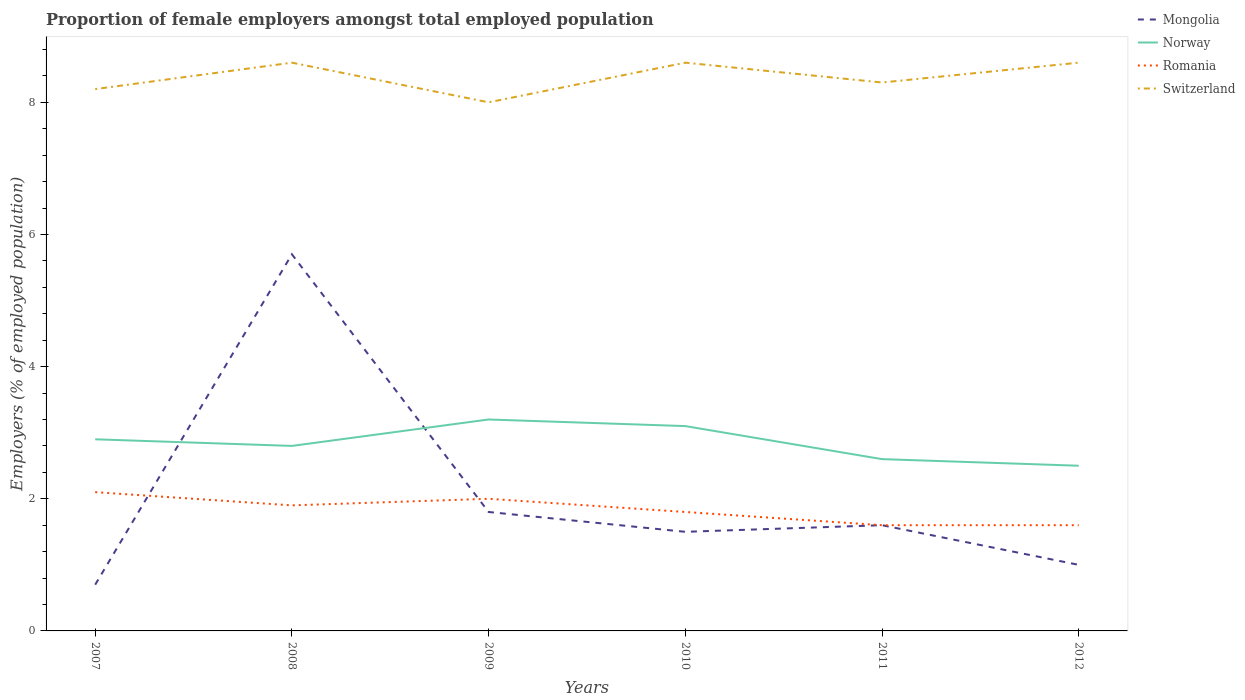Does the line corresponding to Switzerland intersect with the line corresponding to Norway?
Keep it short and to the point. No. In which year was the proportion of female employers in Norway maximum?
Your answer should be compact. 2012. What is the total proportion of female employers in Mongolia in the graph?
Offer a terse response. 4.7. What is the difference between the highest and the second highest proportion of female employers in Switzerland?
Provide a short and direct response. 0.6. What is the difference between the highest and the lowest proportion of female employers in Switzerland?
Your answer should be very brief. 3. Is the proportion of female employers in Norway strictly greater than the proportion of female employers in Romania over the years?
Your answer should be compact. No. How many lines are there?
Offer a very short reply. 4. How many years are there in the graph?
Ensure brevity in your answer.  6. Does the graph contain any zero values?
Offer a terse response. No. Does the graph contain grids?
Your answer should be compact. No. Where does the legend appear in the graph?
Ensure brevity in your answer.  Top right. How are the legend labels stacked?
Offer a very short reply. Vertical. What is the title of the graph?
Offer a very short reply. Proportion of female employers amongst total employed population. What is the label or title of the X-axis?
Keep it short and to the point. Years. What is the label or title of the Y-axis?
Provide a short and direct response. Employers (% of employed population). What is the Employers (% of employed population) in Mongolia in 2007?
Your answer should be compact. 0.7. What is the Employers (% of employed population) in Norway in 2007?
Give a very brief answer. 2.9. What is the Employers (% of employed population) in Romania in 2007?
Make the answer very short. 2.1. What is the Employers (% of employed population) in Switzerland in 2007?
Give a very brief answer. 8.2. What is the Employers (% of employed population) in Mongolia in 2008?
Provide a succinct answer. 5.7. What is the Employers (% of employed population) in Norway in 2008?
Make the answer very short. 2.8. What is the Employers (% of employed population) of Romania in 2008?
Give a very brief answer. 1.9. What is the Employers (% of employed population) of Switzerland in 2008?
Give a very brief answer. 8.6. What is the Employers (% of employed population) of Mongolia in 2009?
Make the answer very short. 1.8. What is the Employers (% of employed population) of Norway in 2009?
Ensure brevity in your answer.  3.2. What is the Employers (% of employed population) in Romania in 2009?
Your response must be concise. 2. What is the Employers (% of employed population) in Norway in 2010?
Ensure brevity in your answer.  3.1. What is the Employers (% of employed population) of Romania in 2010?
Your answer should be compact. 1.8. What is the Employers (% of employed population) in Switzerland in 2010?
Provide a succinct answer. 8.6. What is the Employers (% of employed population) in Mongolia in 2011?
Provide a succinct answer. 1.6. What is the Employers (% of employed population) in Norway in 2011?
Offer a very short reply. 2.6. What is the Employers (% of employed population) in Romania in 2011?
Make the answer very short. 1.6. What is the Employers (% of employed population) of Switzerland in 2011?
Your response must be concise. 8.3. What is the Employers (% of employed population) of Mongolia in 2012?
Offer a very short reply. 1. What is the Employers (% of employed population) of Romania in 2012?
Ensure brevity in your answer.  1.6. What is the Employers (% of employed population) of Switzerland in 2012?
Ensure brevity in your answer.  8.6. Across all years, what is the maximum Employers (% of employed population) in Mongolia?
Make the answer very short. 5.7. Across all years, what is the maximum Employers (% of employed population) in Norway?
Offer a terse response. 3.2. Across all years, what is the maximum Employers (% of employed population) of Romania?
Give a very brief answer. 2.1. Across all years, what is the maximum Employers (% of employed population) of Switzerland?
Ensure brevity in your answer.  8.6. Across all years, what is the minimum Employers (% of employed population) in Mongolia?
Offer a very short reply. 0.7. Across all years, what is the minimum Employers (% of employed population) in Romania?
Provide a short and direct response. 1.6. What is the total Employers (% of employed population) of Mongolia in the graph?
Offer a terse response. 12.3. What is the total Employers (% of employed population) in Switzerland in the graph?
Your response must be concise. 50.3. What is the difference between the Employers (% of employed population) of Norway in 2007 and that in 2008?
Provide a succinct answer. 0.1. What is the difference between the Employers (% of employed population) of Mongolia in 2007 and that in 2009?
Make the answer very short. -1.1. What is the difference between the Employers (% of employed population) in Romania in 2007 and that in 2009?
Keep it short and to the point. 0.1. What is the difference between the Employers (% of employed population) in Switzerland in 2007 and that in 2010?
Keep it short and to the point. -0.4. What is the difference between the Employers (% of employed population) in Mongolia in 2007 and that in 2011?
Provide a short and direct response. -0.9. What is the difference between the Employers (% of employed population) in Norway in 2007 and that in 2011?
Provide a short and direct response. 0.3. What is the difference between the Employers (% of employed population) of Romania in 2007 and that in 2011?
Your response must be concise. 0.5. What is the difference between the Employers (% of employed population) of Switzerland in 2007 and that in 2011?
Offer a terse response. -0.1. What is the difference between the Employers (% of employed population) in Mongolia in 2007 and that in 2012?
Keep it short and to the point. -0.3. What is the difference between the Employers (% of employed population) in Switzerland in 2007 and that in 2012?
Make the answer very short. -0.4. What is the difference between the Employers (% of employed population) in Mongolia in 2008 and that in 2009?
Make the answer very short. 3.9. What is the difference between the Employers (% of employed population) of Switzerland in 2008 and that in 2009?
Your answer should be compact. 0.6. What is the difference between the Employers (% of employed population) in Norway in 2008 and that in 2010?
Make the answer very short. -0.3. What is the difference between the Employers (% of employed population) in Romania in 2008 and that in 2010?
Offer a very short reply. 0.1. What is the difference between the Employers (% of employed population) in Switzerland in 2008 and that in 2010?
Offer a very short reply. 0. What is the difference between the Employers (% of employed population) in Norway in 2008 and that in 2011?
Your response must be concise. 0.2. What is the difference between the Employers (% of employed population) in Romania in 2008 and that in 2011?
Offer a terse response. 0.3. What is the difference between the Employers (% of employed population) in Mongolia in 2008 and that in 2012?
Make the answer very short. 4.7. What is the difference between the Employers (% of employed population) of Norway in 2008 and that in 2012?
Give a very brief answer. 0.3. What is the difference between the Employers (% of employed population) in Switzerland in 2008 and that in 2012?
Offer a very short reply. 0. What is the difference between the Employers (% of employed population) of Mongolia in 2009 and that in 2012?
Provide a succinct answer. 0.8. What is the difference between the Employers (% of employed population) of Mongolia in 2010 and that in 2011?
Give a very brief answer. -0.1. What is the difference between the Employers (% of employed population) in Romania in 2010 and that in 2011?
Provide a short and direct response. 0.2. What is the difference between the Employers (% of employed population) in Switzerland in 2010 and that in 2012?
Offer a very short reply. 0. What is the difference between the Employers (% of employed population) of Norway in 2011 and that in 2012?
Offer a terse response. 0.1. What is the difference between the Employers (% of employed population) in Romania in 2011 and that in 2012?
Offer a very short reply. 0. What is the difference between the Employers (% of employed population) in Mongolia in 2007 and the Employers (% of employed population) in Norway in 2009?
Provide a short and direct response. -2.5. What is the difference between the Employers (% of employed population) of Mongolia in 2007 and the Employers (% of employed population) of Switzerland in 2009?
Ensure brevity in your answer.  -7.3. What is the difference between the Employers (% of employed population) of Norway in 2007 and the Employers (% of employed population) of Romania in 2009?
Ensure brevity in your answer.  0.9. What is the difference between the Employers (% of employed population) in Romania in 2007 and the Employers (% of employed population) in Switzerland in 2009?
Offer a terse response. -5.9. What is the difference between the Employers (% of employed population) in Mongolia in 2007 and the Employers (% of employed population) in Romania in 2010?
Your answer should be compact. -1.1. What is the difference between the Employers (% of employed population) of Mongolia in 2007 and the Employers (% of employed population) of Switzerland in 2010?
Your response must be concise. -7.9. What is the difference between the Employers (% of employed population) in Romania in 2007 and the Employers (% of employed population) in Switzerland in 2010?
Give a very brief answer. -6.5. What is the difference between the Employers (% of employed population) in Mongolia in 2007 and the Employers (% of employed population) in Norway in 2011?
Ensure brevity in your answer.  -1.9. What is the difference between the Employers (% of employed population) in Mongolia in 2007 and the Employers (% of employed population) in Switzerland in 2011?
Your answer should be very brief. -7.6. What is the difference between the Employers (% of employed population) of Norway in 2007 and the Employers (% of employed population) of Switzerland in 2011?
Your response must be concise. -5.4. What is the difference between the Employers (% of employed population) of Mongolia in 2007 and the Employers (% of employed population) of Norway in 2012?
Offer a very short reply. -1.8. What is the difference between the Employers (% of employed population) of Norway in 2007 and the Employers (% of employed population) of Romania in 2012?
Your answer should be compact. 1.3. What is the difference between the Employers (% of employed population) of Romania in 2007 and the Employers (% of employed population) of Switzerland in 2012?
Provide a short and direct response. -6.5. What is the difference between the Employers (% of employed population) of Mongolia in 2008 and the Employers (% of employed population) of Romania in 2009?
Keep it short and to the point. 3.7. What is the difference between the Employers (% of employed population) of Mongolia in 2008 and the Employers (% of employed population) of Switzerland in 2009?
Offer a very short reply. -2.3. What is the difference between the Employers (% of employed population) of Norway in 2008 and the Employers (% of employed population) of Romania in 2009?
Provide a short and direct response. 0.8. What is the difference between the Employers (% of employed population) of Norway in 2008 and the Employers (% of employed population) of Switzerland in 2009?
Provide a succinct answer. -5.2. What is the difference between the Employers (% of employed population) in Romania in 2008 and the Employers (% of employed population) in Switzerland in 2009?
Make the answer very short. -6.1. What is the difference between the Employers (% of employed population) of Mongolia in 2008 and the Employers (% of employed population) of Norway in 2010?
Offer a very short reply. 2.6. What is the difference between the Employers (% of employed population) of Norway in 2008 and the Employers (% of employed population) of Romania in 2010?
Offer a terse response. 1. What is the difference between the Employers (% of employed population) of Romania in 2008 and the Employers (% of employed population) of Switzerland in 2010?
Offer a very short reply. -6.7. What is the difference between the Employers (% of employed population) in Mongolia in 2008 and the Employers (% of employed population) in Norway in 2011?
Ensure brevity in your answer.  3.1. What is the difference between the Employers (% of employed population) in Mongolia in 2008 and the Employers (% of employed population) in Switzerland in 2011?
Offer a terse response. -2.6. What is the difference between the Employers (% of employed population) in Norway in 2008 and the Employers (% of employed population) in Switzerland in 2011?
Ensure brevity in your answer.  -5.5. What is the difference between the Employers (% of employed population) in Mongolia in 2008 and the Employers (% of employed population) in Norway in 2012?
Make the answer very short. 3.2. What is the difference between the Employers (% of employed population) in Mongolia in 2008 and the Employers (% of employed population) in Switzerland in 2012?
Make the answer very short. -2.9. What is the difference between the Employers (% of employed population) in Norway in 2008 and the Employers (% of employed population) in Romania in 2012?
Ensure brevity in your answer.  1.2. What is the difference between the Employers (% of employed population) in Norway in 2009 and the Employers (% of employed population) in Romania in 2010?
Offer a very short reply. 1.4. What is the difference between the Employers (% of employed population) of Romania in 2009 and the Employers (% of employed population) of Switzerland in 2010?
Your response must be concise. -6.6. What is the difference between the Employers (% of employed population) in Mongolia in 2009 and the Employers (% of employed population) in Romania in 2011?
Your answer should be very brief. 0.2. What is the difference between the Employers (% of employed population) of Mongolia in 2009 and the Employers (% of employed population) of Switzerland in 2011?
Give a very brief answer. -6.5. What is the difference between the Employers (% of employed population) in Mongolia in 2009 and the Employers (% of employed population) in Norway in 2012?
Your answer should be compact. -0.7. What is the difference between the Employers (% of employed population) in Mongolia in 2009 and the Employers (% of employed population) in Romania in 2012?
Give a very brief answer. 0.2. What is the difference between the Employers (% of employed population) in Norway in 2009 and the Employers (% of employed population) in Switzerland in 2012?
Offer a terse response. -5.4. What is the difference between the Employers (% of employed population) of Romania in 2009 and the Employers (% of employed population) of Switzerland in 2012?
Provide a succinct answer. -6.6. What is the difference between the Employers (% of employed population) in Mongolia in 2010 and the Employers (% of employed population) in Romania in 2011?
Your response must be concise. -0.1. What is the difference between the Employers (% of employed population) in Norway in 2010 and the Employers (% of employed population) in Romania in 2011?
Give a very brief answer. 1.5. What is the difference between the Employers (% of employed population) of Mongolia in 2010 and the Employers (% of employed population) of Norway in 2012?
Your answer should be compact. -1. What is the difference between the Employers (% of employed population) of Norway in 2010 and the Employers (% of employed population) of Romania in 2012?
Provide a short and direct response. 1.5. What is the difference between the Employers (% of employed population) of Mongolia in 2011 and the Employers (% of employed population) of Romania in 2012?
Your answer should be very brief. 0. What is the difference between the Employers (% of employed population) of Mongolia in 2011 and the Employers (% of employed population) of Switzerland in 2012?
Give a very brief answer. -7. What is the average Employers (% of employed population) in Mongolia per year?
Offer a terse response. 2.05. What is the average Employers (% of employed population) in Norway per year?
Offer a very short reply. 2.85. What is the average Employers (% of employed population) in Romania per year?
Make the answer very short. 1.83. What is the average Employers (% of employed population) of Switzerland per year?
Keep it short and to the point. 8.38. In the year 2007, what is the difference between the Employers (% of employed population) of Mongolia and Employers (% of employed population) of Norway?
Offer a very short reply. -2.2. In the year 2007, what is the difference between the Employers (% of employed population) of Mongolia and Employers (% of employed population) of Switzerland?
Offer a terse response. -7.5. In the year 2007, what is the difference between the Employers (% of employed population) in Norway and Employers (% of employed population) in Romania?
Your answer should be compact. 0.8. In the year 2008, what is the difference between the Employers (% of employed population) of Mongolia and Employers (% of employed population) of Romania?
Make the answer very short. 3.8. In the year 2008, what is the difference between the Employers (% of employed population) in Norway and Employers (% of employed population) in Romania?
Provide a succinct answer. 0.9. In the year 2008, what is the difference between the Employers (% of employed population) in Romania and Employers (% of employed population) in Switzerland?
Provide a short and direct response. -6.7. In the year 2010, what is the difference between the Employers (% of employed population) in Mongolia and Employers (% of employed population) in Romania?
Your answer should be compact. -0.3. In the year 2010, what is the difference between the Employers (% of employed population) in Mongolia and Employers (% of employed population) in Switzerland?
Provide a short and direct response. -7.1. In the year 2010, what is the difference between the Employers (% of employed population) in Norway and Employers (% of employed population) in Romania?
Offer a very short reply. 1.3. In the year 2010, what is the difference between the Employers (% of employed population) of Norway and Employers (% of employed population) of Switzerland?
Offer a terse response. -5.5. In the year 2010, what is the difference between the Employers (% of employed population) of Romania and Employers (% of employed population) of Switzerland?
Give a very brief answer. -6.8. In the year 2011, what is the difference between the Employers (% of employed population) of Mongolia and Employers (% of employed population) of Norway?
Your answer should be compact. -1. In the year 2011, what is the difference between the Employers (% of employed population) of Mongolia and Employers (% of employed population) of Romania?
Offer a terse response. 0. In the year 2012, what is the difference between the Employers (% of employed population) in Mongolia and Employers (% of employed population) in Norway?
Provide a short and direct response. -1.5. In the year 2012, what is the difference between the Employers (% of employed population) of Norway and Employers (% of employed population) of Switzerland?
Your answer should be very brief. -6.1. What is the ratio of the Employers (% of employed population) of Mongolia in 2007 to that in 2008?
Your answer should be very brief. 0.12. What is the ratio of the Employers (% of employed population) in Norway in 2007 to that in 2008?
Provide a succinct answer. 1.04. What is the ratio of the Employers (% of employed population) in Romania in 2007 to that in 2008?
Provide a succinct answer. 1.11. What is the ratio of the Employers (% of employed population) in Switzerland in 2007 to that in 2008?
Ensure brevity in your answer.  0.95. What is the ratio of the Employers (% of employed population) of Mongolia in 2007 to that in 2009?
Offer a very short reply. 0.39. What is the ratio of the Employers (% of employed population) of Norway in 2007 to that in 2009?
Offer a very short reply. 0.91. What is the ratio of the Employers (% of employed population) in Romania in 2007 to that in 2009?
Your response must be concise. 1.05. What is the ratio of the Employers (% of employed population) in Switzerland in 2007 to that in 2009?
Offer a very short reply. 1.02. What is the ratio of the Employers (% of employed population) of Mongolia in 2007 to that in 2010?
Your response must be concise. 0.47. What is the ratio of the Employers (% of employed population) in Norway in 2007 to that in 2010?
Provide a succinct answer. 0.94. What is the ratio of the Employers (% of employed population) in Switzerland in 2007 to that in 2010?
Your answer should be compact. 0.95. What is the ratio of the Employers (% of employed population) of Mongolia in 2007 to that in 2011?
Ensure brevity in your answer.  0.44. What is the ratio of the Employers (% of employed population) in Norway in 2007 to that in 2011?
Your answer should be very brief. 1.12. What is the ratio of the Employers (% of employed population) of Romania in 2007 to that in 2011?
Your answer should be very brief. 1.31. What is the ratio of the Employers (% of employed population) of Switzerland in 2007 to that in 2011?
Make the answer very short. 0.99. What is the ratio of the Employers (% of employed population) in Mongolia in 2007 to that in 2012?
Offer a terse response. 0.7. What is the ratio of the Employers (% of employed population) in Norway in 2007 to that in 2012?
Offer a very short reply. 1.16. What is the ratio of the Employers (% of employed population) of Romania in 2007 to that in 2012?
Give a very brief answer. 1.31. What is the ratio of the Employers (% of employed population) of Switzerland in 2007 to that in 2012?
Ensure brevity in your answer.  0.95. What is the ratio of the Employers (% of employed population) in Mongolia in 2008 to that in 2009?
Ensure brevity in your answer.  3.17. What is the ratio of the Employers (% of employed population) in Norway in 2008 to that in 2009?
Offer a very short reply. 0.88. What is the ratio of the Employers (% of employed population) of Switzerland in 2008 to that in 2009?
Offer a very short reply. 1.07. What is the ratio of the Employers (% of employed population) of Norway in 2008 to that in 2010?
Your answer should be very brief. 0.9. What is the ratio of the Employers (% of employed population) of Romania in 2008 to that in 2010?
Your response must be concise. 1.06. What is the ratio of the Employers (% of employed population) in Switzerland in 2008 to that in 2010?
Give a very brief answer. 1. What is the ratio of the Employers (% of employed population) in Mongolia in 2008 to that in 2011?
Your response must be concise. 3.56. What is the ratio of the Employers (% of employed population) of Norway in 2008 to that in 2011?
Keep it short and to the point. 1.08. What is the ratio of the Employers (% of employed population) of Romania in 2008 to that in 2011?
Provide a succinct answer. 1.19. What is the ratio of the Employers (% of employed population) of Switzerland in 2008 to that in 2011?
Give a very brief answer. 1.04. What is the ratio of the Employers (% of employed population) in Norway in 2008 to that in 2012?
Give a very brief answer. 1.12. What is the ratio of the Employers (% of employed population) of Romania in 2008 to that in 2012?
Your answer should be compact. 1.19. What is the ratio of the Employers (% of employed population) in Norway in 2009 to that in 2010?
Provide a succinct answer. 1.03. What is the ratio of the Employers (% of employed population) of Romania in 2009 to that in 2010?
Your answer should be compact. 1.11. What is the ratio of the Employers (% of employed population) of Switzerland in 2009 to that in 2010?
Your answer should be compact. 0.93. What is the ratio of the Employers (% of employed population) in Mongolia in 2009 to that in 2011?
Make the answer very short. 1.12. What is the ratio of the Employers (% of employed population) of Norway in 2009 to that in 2011?
Offer a terse response. 1.23. What is the ratio of the Employers (% of employed population) of Switzerland in 2009 to that in 2011?
Ensure brevity in your answer.  0.96. What is the ratio of the Employers (% of employed population) of Mongolia in 2009 to that in 2012?
Provide a short and direct response. 1.8. What is the ratio of the Employers (% of employed population) in Norway in 2009 to that in 2012?
Your response must be concise. 1.28. What is the ratio of the Employers (% of employed population) of Romania in 2009 to that in 2012?
Make the answer very short. 1.25. What is the ratio of the Employers (% of employed population) of Switzerland in 2009 to that in 2012?
Keep it short and to the point. 0.93. What is the ratio of the Employers (% of employed population) of Norway in 2010 to that in 2011?
Keep it short and to the point. 1.19. What is the ratio of the Employers (% of employed population) of Switzerland in 2010 to that in 2011?
Provide a succinct answer. 1.04. What is the ratio of the Employers (% of employed population) in Mongolia in 2010 to that in 2012?
Offer a terse response. 1.5. What is the ratio of the Employers (% of employed population) in Norway in 2010 to that in 2012?
Provide a short and direct response. 1.24. What is the ratio of the Employers (% of employed population) in Romania in 2010 to that in 2012?
Ensure brevity in your answer.  1.12. What is the ratio of the Employers (% of employed population) of Switzerland in 2010 to that in 2012?
Keep it short and to the point. 1. What is the ratio of the Employers (% of employed population) of Mongolia in 2011 to that in 2012?
Provide a succinct answer. 1.6. What is the ratio of the Employers (% of employed population) in Norway in 2011 to that in 2012?
Provide a short and direct response. 1.04. What is the ratio of the Employers (% of employed population) in Switzerland in 2011 to that in 2012?
Offer a very short reply. 0.97. What is the difference between the highest and the second highest Employers (% of employed population) in Romania?
Your answer should be compact. 0.1. What is the difference between the highest and the second highest Employers (% of employed population) in Switzerland?
Provide a short and direct response. 0. What is the difference between the highest and the lowest Employers (% of employed population) of Mongolia?
Give a very brief answer. 5. What is the difference between the highest and the lowest Employers (% of employed population) in Norway?
Your answer should be very brief. 0.7. What is the difference between the highest and the lowest Employers (% of employed population) of Romania?
Make the answer very short. 0.5. 